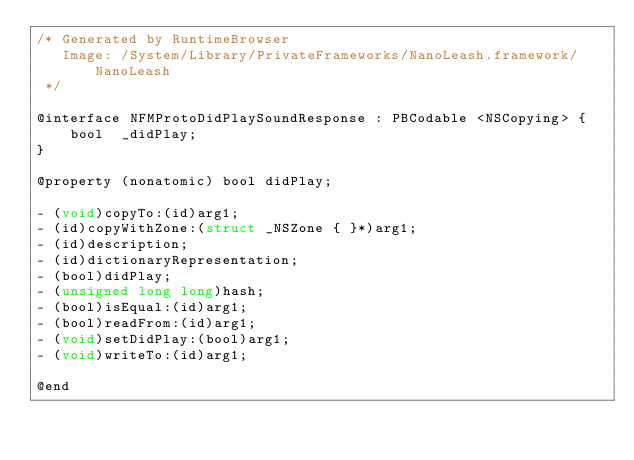Convert code to text. <code><loc_0><loc_0><loc_500><loc_500><_C_>/* Generated by RuntimeBrowser
   Image: /System/Library/PrivateFrameworks/NanoLeash.framework/NanoLeash
 */

@interface NFMProtoDidPlaySoundResponse : PBCodable <NSCopying> {
    bool  _didPlay;
}

@property (nonatomic) bool didPlay;

- (void)copyTo:(id)arg1;
- (id)copyWithZone:(struct _NSZone { }*)arg1;
- (id)description;
- (id)dictionaryRepresentation;
- (bool)didPlay;
- (unsigned long long)hash;
- (bool)isEqual:(id)arg1;
- (bool)readFrom:(id)arg1;
- (void)setDidPlay:(bool)arg1;
- (void)writeTo:(id)arg1;

@end
</code> 